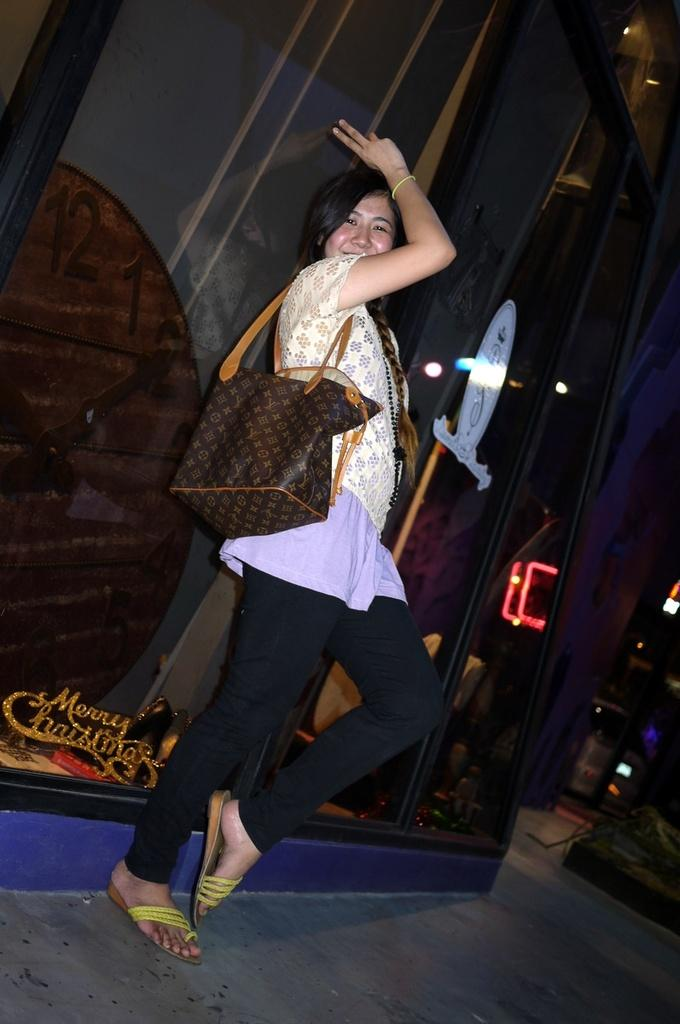Who is the main subject in the image? There is a woman in the image. Where is the woman positioned in the image? The woman is standing in the middle of the image. What is the woman's facial expression? The woman is smiling. What can be seen behind the woman? There is a wall behind the woman. What type of jewel is the woman wearing on her forehead in the image? There is no jewel visible on the woman's forehead in the image. 